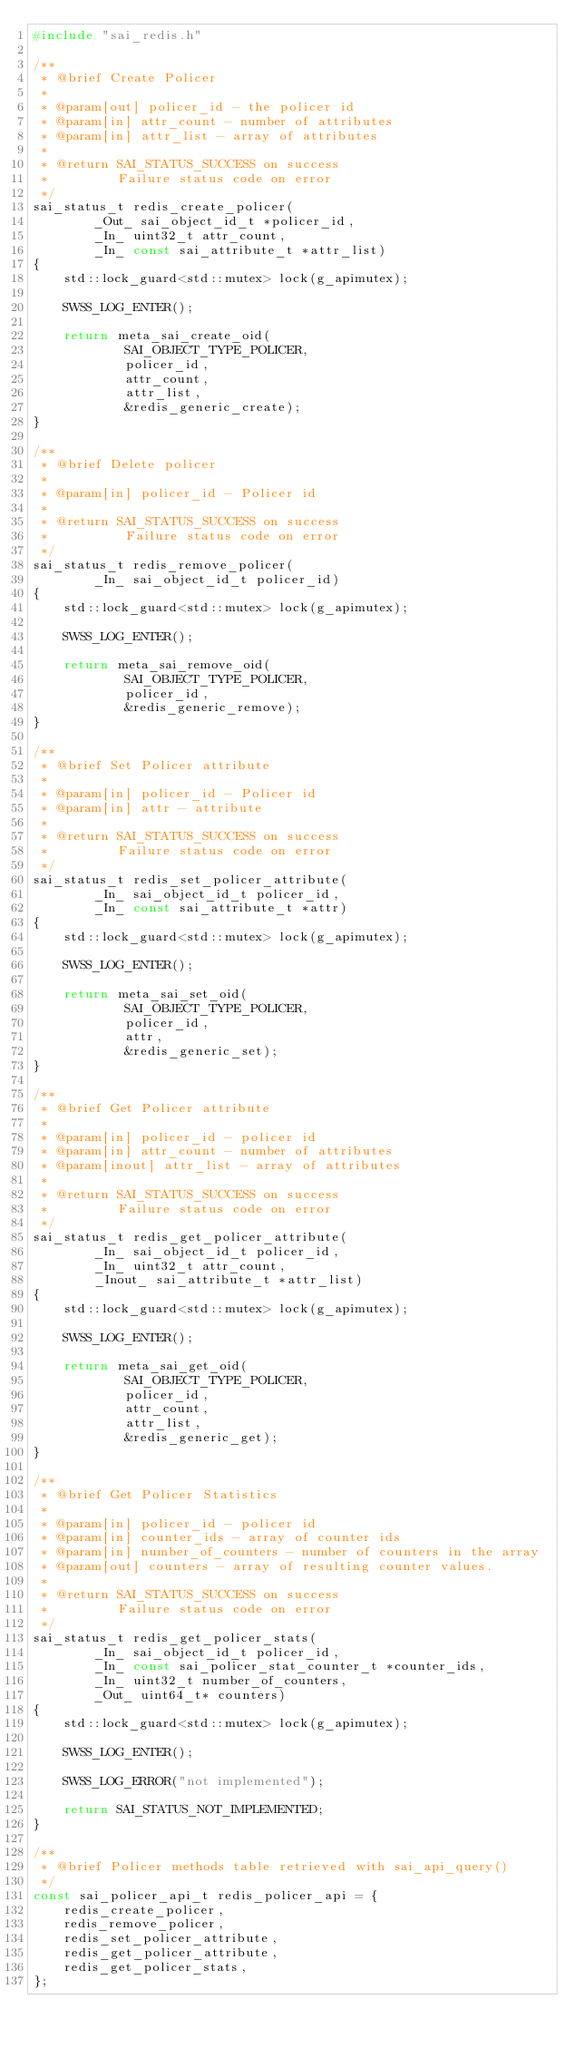<code> <loc_0><loc_0><loc_500><loc_500><_C++_>#include "sai_redis.h"

/**
 * @brief Create Policer
 *
 * @param[out] policer_id - the policer id
 * @param[in] attr_count - number of attributes
 * @param[in] attr_list - array of attributes
 *
 * @return SAI_STATUS_SUCCESS on success
 *         Failure status code on error
 */
sai_status_t redis_create_policer(
        _Out_ sai_object_id_t *policer_id,
        _In_ uint32_t attr_count,
        _In_ const sai_attribute_t *attr_list)
{
    std::lock_guard<std::mutex> lock(g_apimutex);

    SWSS_LOG_ENTER();

    return meta_sai_create_oid(
            SAI_OBJECT_TYPE_POLICER,
            policer_id,
            attr_count,
            attr_list,
            &redis_generic_create);
}

/**
 * @brief Delete policer
 *
 * @param[in] policer_id - Policer id
 *
 * @return SAI_STATUS_SUCCESS on success
 *          Failure status code on error
 */
sai_status_t redis_remove_policer(
        _In_ sai_object_id_t policer_id)
{
    std::lock_guard<std::mutex> lock(g_apimutex);

    SWSS_LOG_ENTER();

    return meta_sai_remove_oid(
            SAI_OBJECT_TYPE_POLICER,
            policer_id,
            &redis_generic_remove);
}

/**
 * @brief Set Policer attribute
 *
 * @param[in] policer_id - Policer id
 * @param[in] attr - attribute
 *
 * @return SAI_STATUS_SUCCESS on success
 *         Failure status code on error
 */
sai_status_t redis_set_policer_attribute(
        _In_ sai_object_id_t policer_id,
        _In_ const sai_attribute_t *attr)
{
    std::lock_guard<std::mutex> lock(g_apimutex);

    SWSS_LOG_ENTER();

    return meta_sai_set_oid(
            SAI_OBJECT_TYPE_POLICER,
            policer_id,
            attr,
            &redis_generic_set);
}

/**
 * @brief Get Policer attribute
 *
 * @param[in] policer_id - policer id
 * @param[in] attr_count - number of attributes
 * @param[inout] attr_list - array of attributes
 *
 * @return SAI_STATUS_SUCCESS on success
 *         Failure status code on error
 */
sai_status_t redis_get_policer_attribute(
        _In_ sai_object_id_t policer_id,
        _In_ uint32_t attr_count,
        _Inout_ sai_attribute_t *attr_list)
{
    std::lock_guard<std::mutex> lock(g_apimutex);

    SWSS_LOG_ENTER();

    return meta_sai_get_oid(
            SAI_OBJECT_TYPE_POLICER,
            policer_id,
            attr_count,
            attr_list,
            &redis_generic_get);
}

/**
 * @brief Get Policer Statistics
 *
 * @param[in] policer_id - policer id
 * @param[in] counter_ids - array of counter ids
 * @param[in] number_of_counters - number of counters in the array
 * @param[out] counters - array of resulting counter values.
 *
 * @return SAI_STATUS_SUCCESS on success
 *         Failure status code on error
 */
sai_status_t redis_get_policer_stats(
        _In_ sai_object_id_t policer_id,
        _In_ const sai_policer_stat_counter_t *counter_ids,
        _In_ uint32_t number_of_counters,
        _Out_ uint64_t* counters)
{
    std::lock_guard<std::mutex> lock(g_apimutex);

    SWSS_LOG_ENTER();

    SWSS_LOG_ERROR("not implemented");

    return SAI_STATUS_NOT_IMPLEMENTED;
}

/**
 * @brief Policer methods table retrieved with sai_api_query()
 */
const sai_policer_api_t redis_policer_api = {
    redis_create_policer,
    redis_remove_policer,
    redis_set_policer_attribute,
    redis_get_policer_attribute,
    redis_get_policer_stats,
};
</code> 